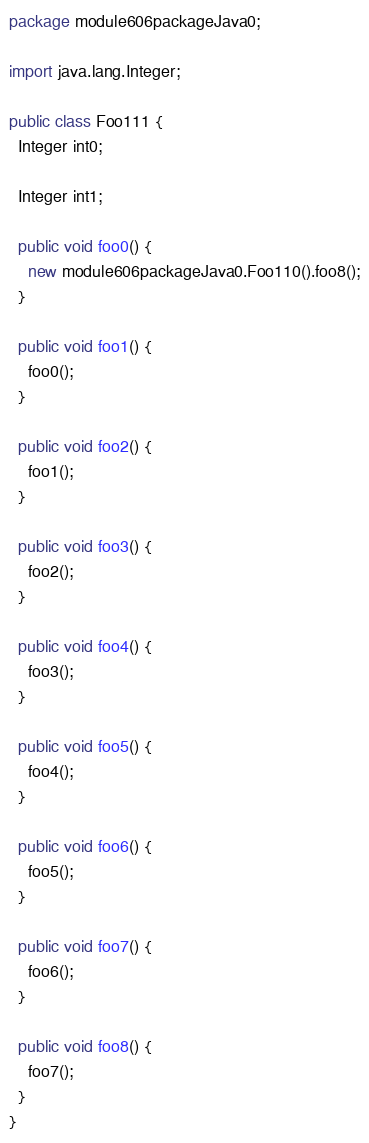Convert code to text. <code><loc_0><loc_0><loc_500><loc_500><_Java_>package module606packageJava0;

import java.lang.Integer;

public class Foo111 {
  Integer int0;

  Integer int1;

  public void foo0() {
    new module606packageJava0.Foo110().foo8();
  }

  public void foo1() {
    foo0();
  }

  public void foo2() {
    foo1();
  }

  public void foo3() {
    foo2();
  }

  public void foo4() {
    foo3();
  }

  public void foo5() {
    foo4();
  }

  public void foo6() {
    foo5();
  }

  public void foo7() {
    foo6();
  }

  public void foo8() {
    foo7();
  }
}
</code> 